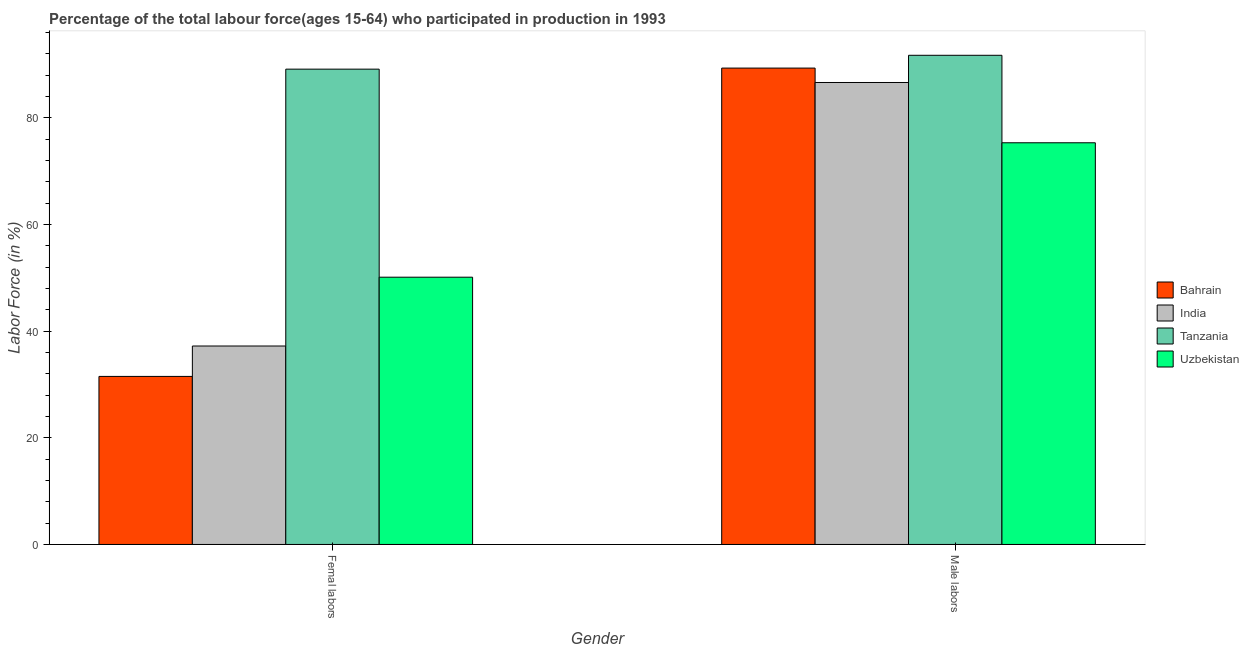How many different coloured bars are there?
Offer a very short reply. 4. Are the number of bars on each tick of the X-axis equal?
Give a very brief answer. Yes. How many bars are there on the 2nd tick from the left?
Offer a terse response. 4. How many bars are there on the 1st tick from the right?
Give a very brief answer. 4. What is the label of the 2nd group of bars from the left?
Offer a very short reply. Male labors. What is the percentage of female labor force in Bahrain?
Provide a short and direct response. 31.5. Across all countries, what is the maximum percentage of female labor force?
Provide a succinct answer. 89.1. Across all countries, what is the minimum percentage of male labour force?
Keep it short and to the point. 75.3. In which country was the percentage of male labour force maximum?
Offer a very short reply. Tanzania. In which country was the percentage of female labor force minimum?
Your response must be concise. Bahrain. What is the total percentage of female labor force in the graph?
Your answer should be compact. 207.9. What is the difference between the percentage of male labour force in Bahrain and that in Tanzania?
Give a very brief answer. -2.4. What is the difference between the percentage of male labour force in Uzbekistan and the percentage of female labor force in India?
Keep it short and to the point. 38.1. What is the average percentage of male labour force per country?
Provide a succinct answer. 85.73. What is the difference between the percentage of female labor force and percentage of male labour force in Bahrain?
Your response must be concise. -57.8. What is the ratio of the percentage of female labor force in Bahrain to that in Tanzania?
Your answer should be very brief. 0.35. Is the percentage of female labor force in Tanzania less than that in Bahrain?
Provide a succinct answer. No. In how many countries, is the percentage of male labour force greater than the average percentage of male labour force taken over all countries?
Give a very brief answer. 3. What does the 2nd bar from the left in Femal labors represents?
Give a very brief answer. India. Does the graph contain any zero values?
Offer a terse response. No. Does the graph contain grids?
Ensure brevity in your answer.  No. Where does the legend appear in the graph?
Provide a short and direct response. Center right. How many legend labels are there?
Keep it short and to the point. 4. What is the title of the graph?
Give a very brief answer. Percentage of the total labour force(ages 15-64) who participated in production in 1993. Does "Micronesia" appear as one of the legend labels in the graph?
Provide a short and direct response. No. What is the label or title of the X-axis?
Keep it short and to the point. Gender. What is the Labor Force (in %) of Bahrain in Femal labors?
Give a very brief answer. 31.5. What is the Labor Force (in %) of India in Femal labors?
Provide a short and direct response. 37.2. What is the Labor Force (in %) of Tanzania in Femal labors?
Your response must be concise. 89.1. What is the Labor Force (in %) of Uzbekistan in Femal labors?
Make the answer very short. 50.1. What is the Labor Force (in %) in Bahrain in Male labors?
Your response must be concise. 89.3. What is the Labor Force (in %) in India in Male labors?
Your answer should be very brief. 86.6. What is the Labor Force (in %) of Tanzania in Male labors?
Your response must be concise. 91.7. What is the Labor Force (in %) in Uzbekistan in Male labors?
Give a very brief answer. 75.3. Across all Gender, what is the maximum Labor Force (in %) of Bahrain?
Give a very brief answer. 89.3. Across all Gender, what is the maximum Labor Force (in %) in India?
Make the answer very short. 86.6. Across all Gender, what is the maximum Labor Force (in %) of Tanzania?
Give a very brief answer. 91.7. Across all Gender, what is the maximum Labor Force (in %) of Uzbekistan?
Offer a terse response. 75.3. Across all Gender, what is the minimum Labor Force (in %) in Bahrain?
Offer a terse response. 31.5. Across all Gender, what is the minimum Labor Force (in %) in India?
Your response must be concise. 37.2. Across all Gender, what is the minimum Labor Force (in %) in Tanzania?
Your answer should be very brief. 89.1. Across all Gender, what is the minimum Labor Force (in %) in Uzbekistan?
Provide a short and direct response. 50.1. What is the total Labor Force (in %) of Bahrain in the graph?
Keep it short and to the point. 120.8. What is the total Labor Force (in %) of India in the graph?
Your answer should be compact. 123.8. What is the total Labor Force (in %) in Tanzania in the graph?
Ensure brevity in your answer.  180.8. What is the total Labor Force (in %) of Uzbekistan in the graph?
Ensure brevity in your answer.  125.4. What is the difference between the Labor Force (in %) in Bahrain in Femal labors and that in Male labors?
Provide a succinct answer. -57.8. What is the difference between the Labor Force (in %) in India in Femal labors and that in Male labors?
Give a very brief answer. -49.4. What is the difference between the Labor Force (in %) of Tanzania in Femal labors and that in Male labors?
Your response must be concise. -2.6. What is the difference between the Labor Force (in %) of Uzbekistan in Femal labors and that in Male labors?
Your response must be concise. -25.2. What is the difference between the Labor Force (in %) of Bahrain in Femal labors and the Labor Force (in %) of India in Male labors?
Your response must be concise. -55.1. What is the difference between the Labor Force (in %) in Bahrain in Femal labors and the Labor Force (in %) in Tanzania in Male labors?
Give a very brief answer. -60.2. What is the difference between the Labor Force (in %) of Bahrain in Femal labors and the Labor Force (in %) of Uzbekistan in Male labors?
Your answer should be very brief. -43.8. What is the difference between the Labor Force (in %) in India in Femal labors and the Labor Force (in %) in Tanzania in Male labors?
Offer a terse response. -54.5. What is the difference between the Labor Force (in %) of India in Femal labors and the Labor Force (in %) of Uzbekistan in Male labors?
Your answer should be compact. -38.1. What is the difference between the Labor Force (in %) of Tanzania in Femal labors and the Labor Force (in %) of Uzbekistan in Male labors?
Ensure brevity in your answer.  13.8. What is the average Labor Force (in %) in Bahrain per Gender?
Give a very brief answer. 60.4. What is the average Labor Force (in %) of India per Gender?
Provide a short and direct response. 61.9. What is the average Labor Force (in %) of Tanzania per Gender?
Your answer should be compact. 90.4. What is the average Labor Force (in %) in Uzbekistan per Gender?
Make the answer very short. 62.7. What is the difference between the Labor Force (in %) in Bahrain and Labor Force (in %) in India in Femal labors?
Offer a very short reply. -5.7. What is the difference between the Labor Force (in %) of Bahrain and Labor Force (in %) of Tanzania in Femal labors?
Ensure brevity in your answer.  -57.6. What is the difference between the Labor Force (in %) in Bahrain and Labor Force (in %) in Uzbekistan in Femal labors?
Ensure brevity in your answer.  -18.6. What is the difference between the Labor Force (in %) in India and Labor Force (in %) in Tanzania in Femal labors?
Give a very brief answer. -51.9. What is the difference between the Labor Force (in %) in Bahrain and Labor Force (in %) in Tanzania in Male labors?
Give a very brief answer. -2.4. What is the difference between the Labor Force (in %) of Bahrain and Labor Force (in %) of Uzbekistan in Male labors?
Your response must be concise. 14. What is the difference between the Labor Force (in %) in India and Labor Force (in %) in Uzbekistan in Male labors?
Give a very brief answer. 11.3. What is the ratio of the Labor Force (in %) of Bahrain in Femal labors to that in Male labors?
Make the answer very short. 0.35. What is the ratio of the Labor Force (in %) in India in Femal labors to that in Male labors?
Make the answer very short. 0.43. What is the ratio of the Labor Force (in %) in Tanzania in Femal labors to that in Male labors?
Provide a succinct answer. 0.97. What is the ratio of the Labor Force (in %) in Uzbekistan in Femal labors to that in Male labors?
Offer a very short reply. 0.67. What is the difference between the highest and the second highest Labor Force (in %) in Bahrain?
Give a very brief answer. 57.8. What is the difference between the highest and the second highest Labor Force (in %) in India?
Ensure brevity in your answer.  49.4. What is the difference between the highest and the second highest Labor Force (in %) in Uzbekistan?
Your response must be concise. 25.2. What is the difference between the highest and the lowest Labor Force (in %) of Bahrain?
Give a very brief answer. 57.8. What is the difference between the highest and the lowest Labor Force (in %) in India?
Make the answer very short. 49.4. What is the difference between the highest and the lowest Labor Force (in %) of Tanzania?
Provide a short and direct response. 2.6. What is the difference between the highest and the lowest Labor Force (in %) in Uzbekistan?
Make the answer very short. 25.2. 